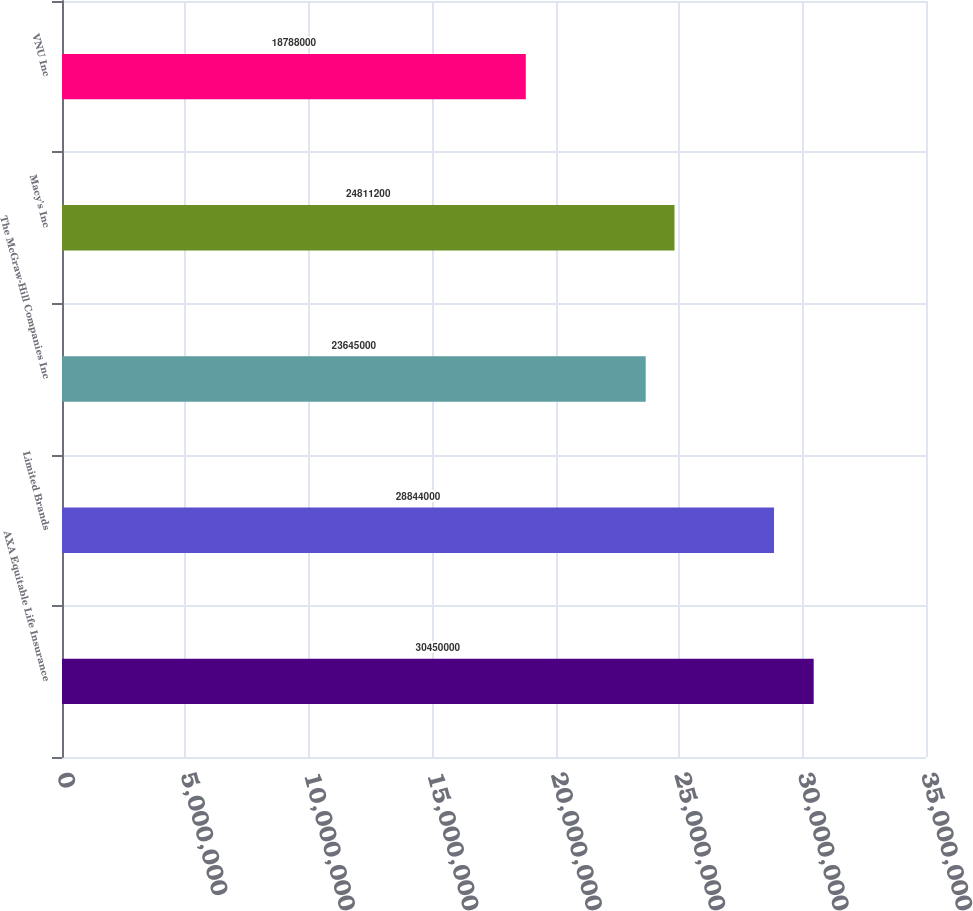Convert chart to OTSL. <chart><loc_0><loc_0><loc_500><loc_500><bar_chart><fcel>AXA Equitable Life Insurance<fcel>Limited Brands<fcel>The McGraw-Hill Companies Inc<fcel>Macy's Inc<fcel>VNU Inc<nl><fcel>3.045e+07<fcel>2.8844e+07<fcel>2.3645e+07<fcel>2.48112e+07<fcel>1.8788e+07<nl></chart> 